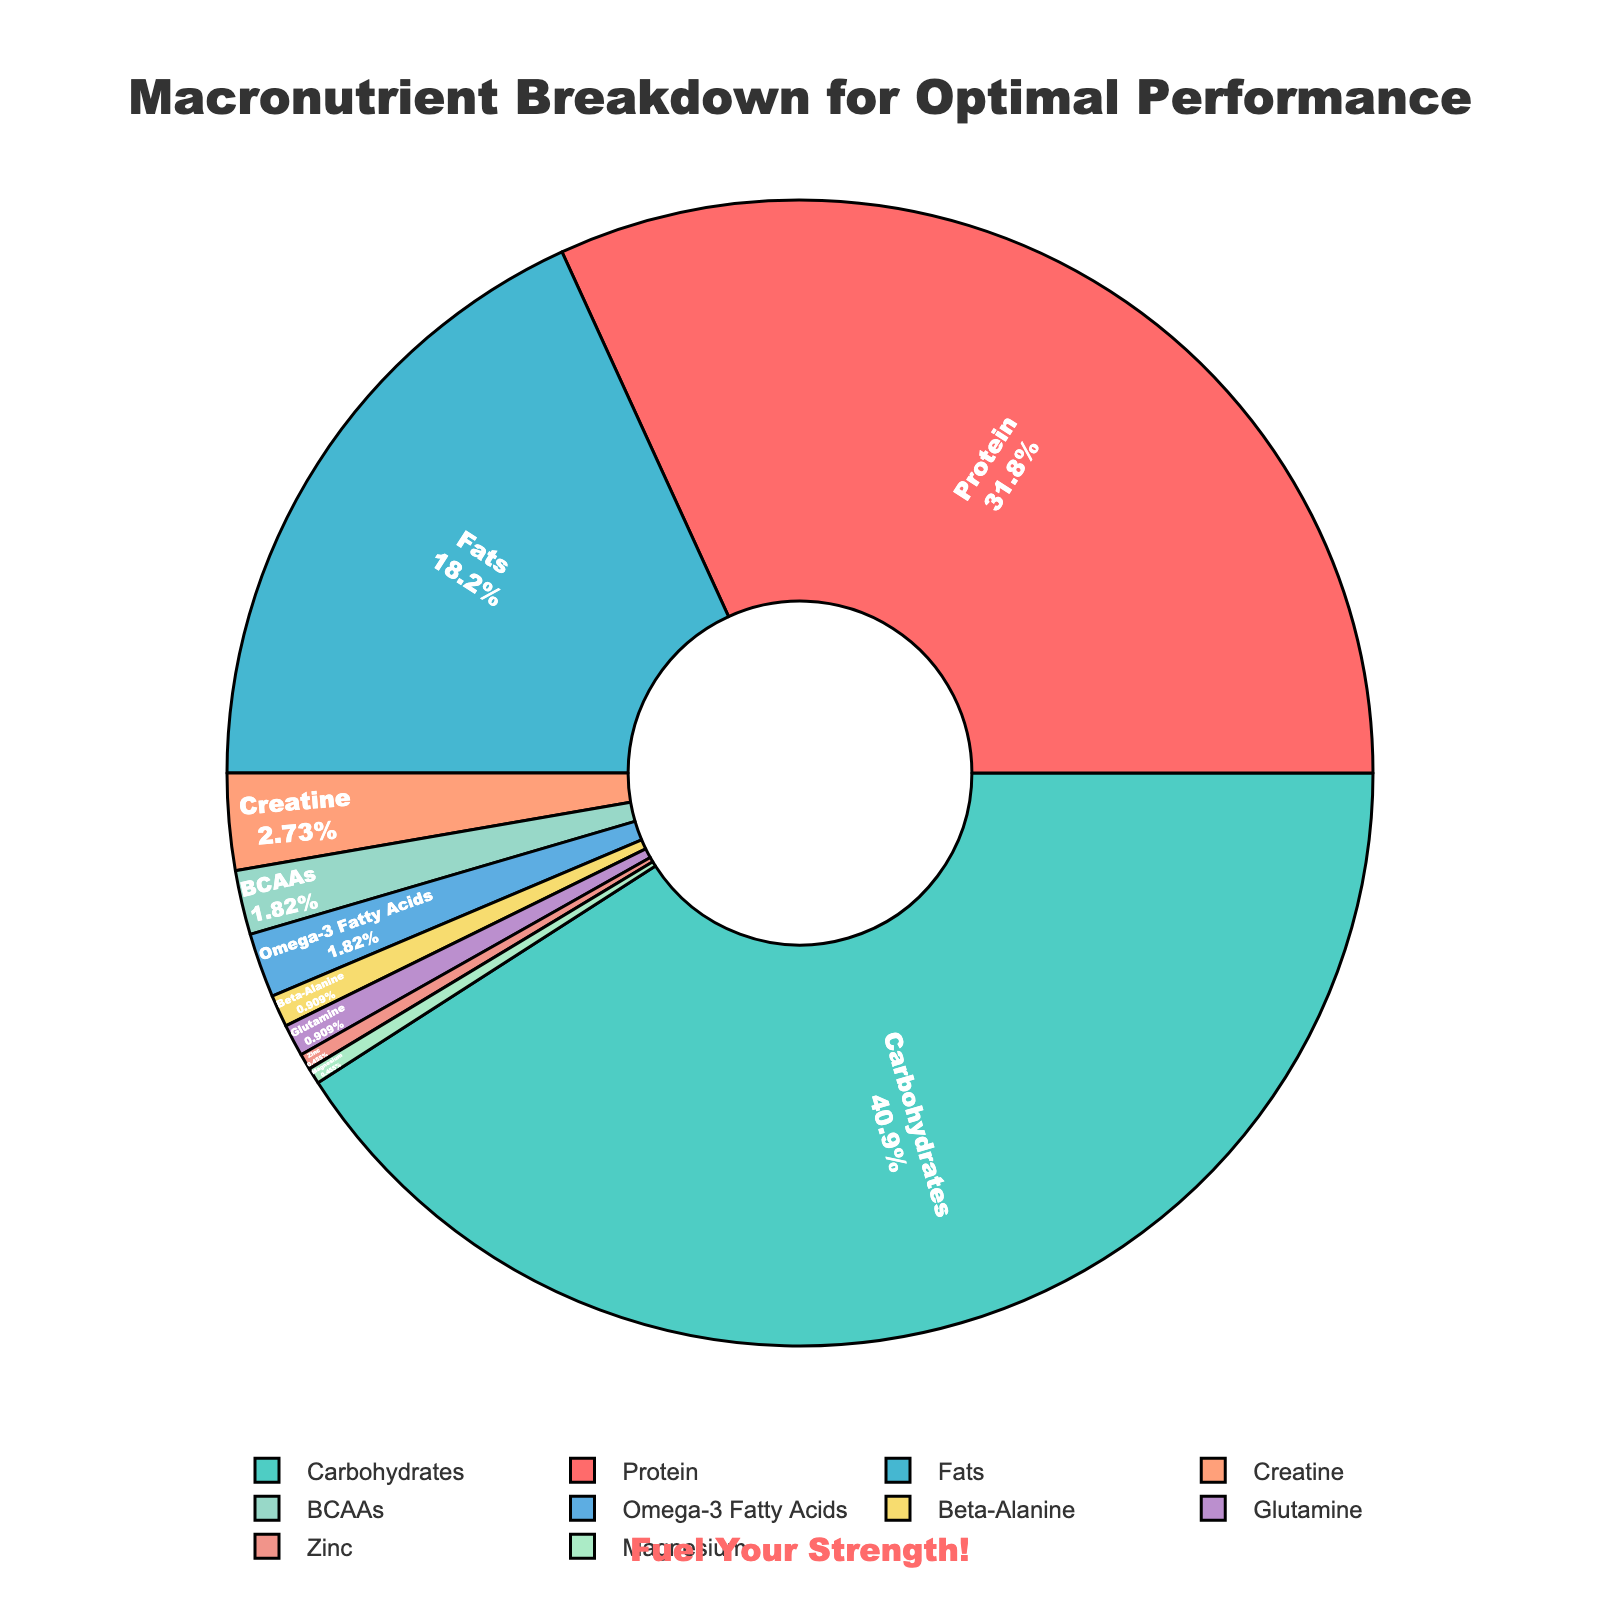What percentage of the chart is dedicated to carbohydrates? According to the figure, the slice labeled "Carbohydrates" takes up 45% of the pie chart.
Answer: 45% What is the combined percentage of Protein and Fats? The Protein slice is 35% and the Fats slice is 20%. Adding them together gives 35% + 20% = 55%.
Answer: 55% How does the percentage of BCAAs compare to the percentage of Glutamine? The figure shows that BCAAs are 2% and Glutamine is 1%. Therefore, BCAAs have a higher percentage than Glutamine.
Answer: BCAAs have a higher percentage What is the least represented macronutrient on the chart? The figure indicates that Zinc and Magnesium each contribute 0.5%, making them the least represented macronutrients.
Answer: Zinc and Magnesium (0.5% each) What is the percentage difference between Creatine and Omega-3 Fatty Acids? Creatine occupies 3% of the chart, while Omega-3 Fatty Acids account for 2%. The difference is 3% - 2% = 1%.
Answer: 1% What fraction of the whole chart is made up of performance supplements like Creatine, BCAAs, Beta-Alanine, Glutamine, Zinc, and Magnesium? Adding up their percentages: Creatine (3%) + BCAAs (2%) + Beta-Alanine (1%) + Glutamine (1%) + Zinc (0.5%) + Magnesium (0.5%) = 8%.
Answer: 8% Is there more space dedicated to Fats or Proteins on the chart? The chart assigns 20% to Fats and 35% to Proteins, so Proteins have more space.
Answer: Proteins What is the combined percentage of all micronutrients listed? The micronutrients on the chart are Omega-3 Fatty Acids (2%), Zinc (0.5%), and Magnesium (0.5%). Adding these gives 2% + 0.5% + 0.5% = 3%.
Answer: 3% Which macronutrient has the third largest percentage on the chart? The chart shows that Fats make up the third largest percentage at 20%, following Carbohydrates (45%) and Proteins (35%).
Answer: Fats (20%) If the goal is to increase Protein intake by 5% of the total chart, what would the new percentage be? The original percentage for Protein is 35%. Increasing it by 5% of the total chart yields 35% + 5% = 40%.
Answer: 40% 